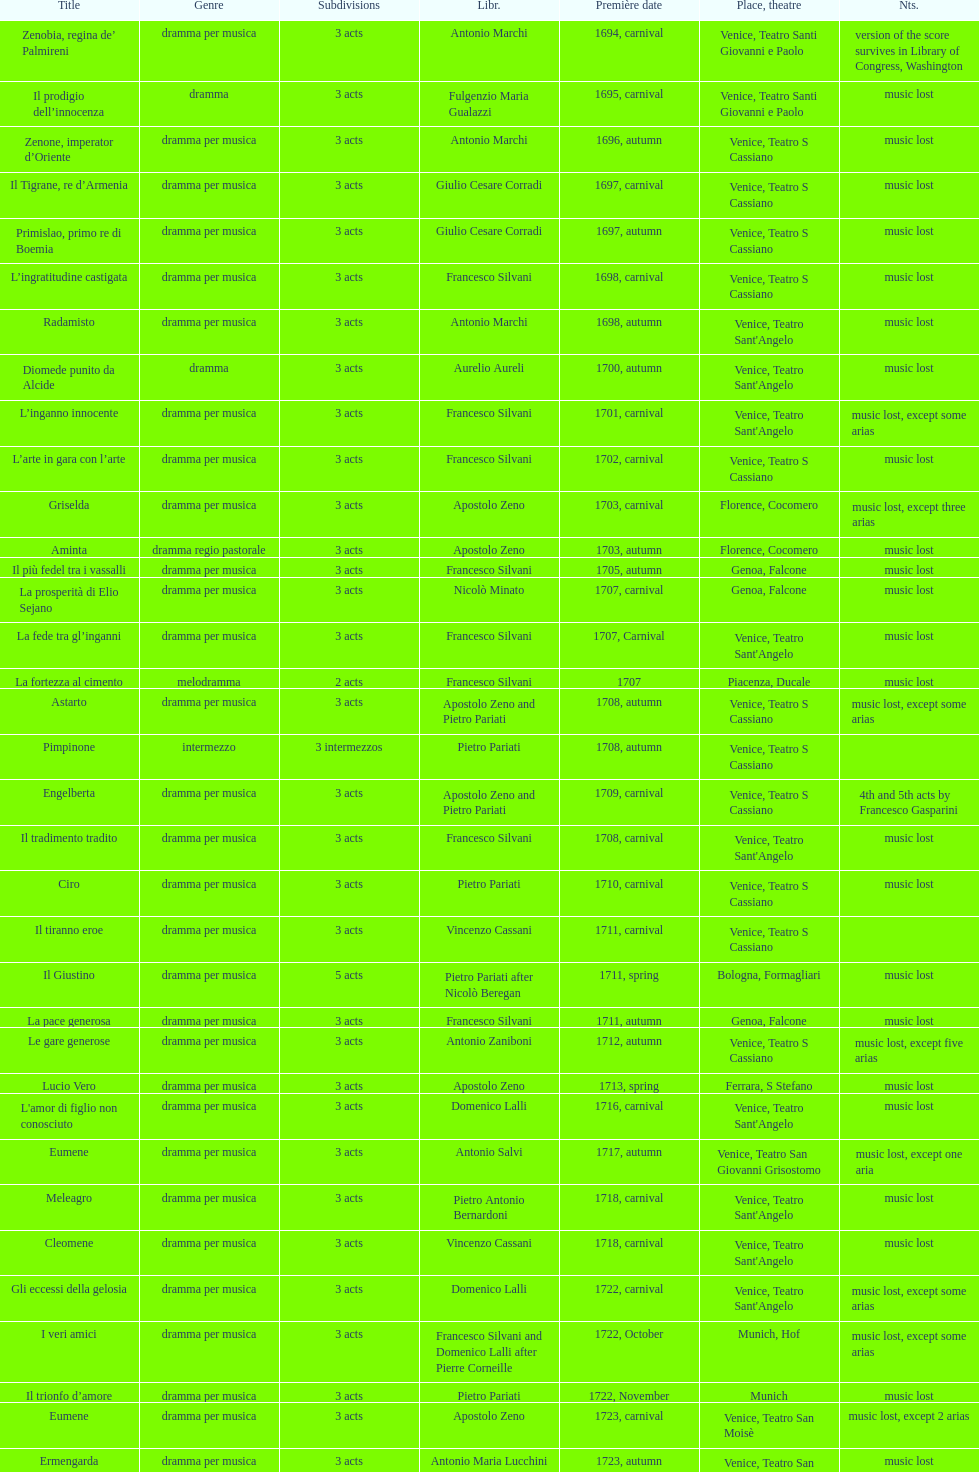How many were released after zenone, imperator d'oriente? 52. 